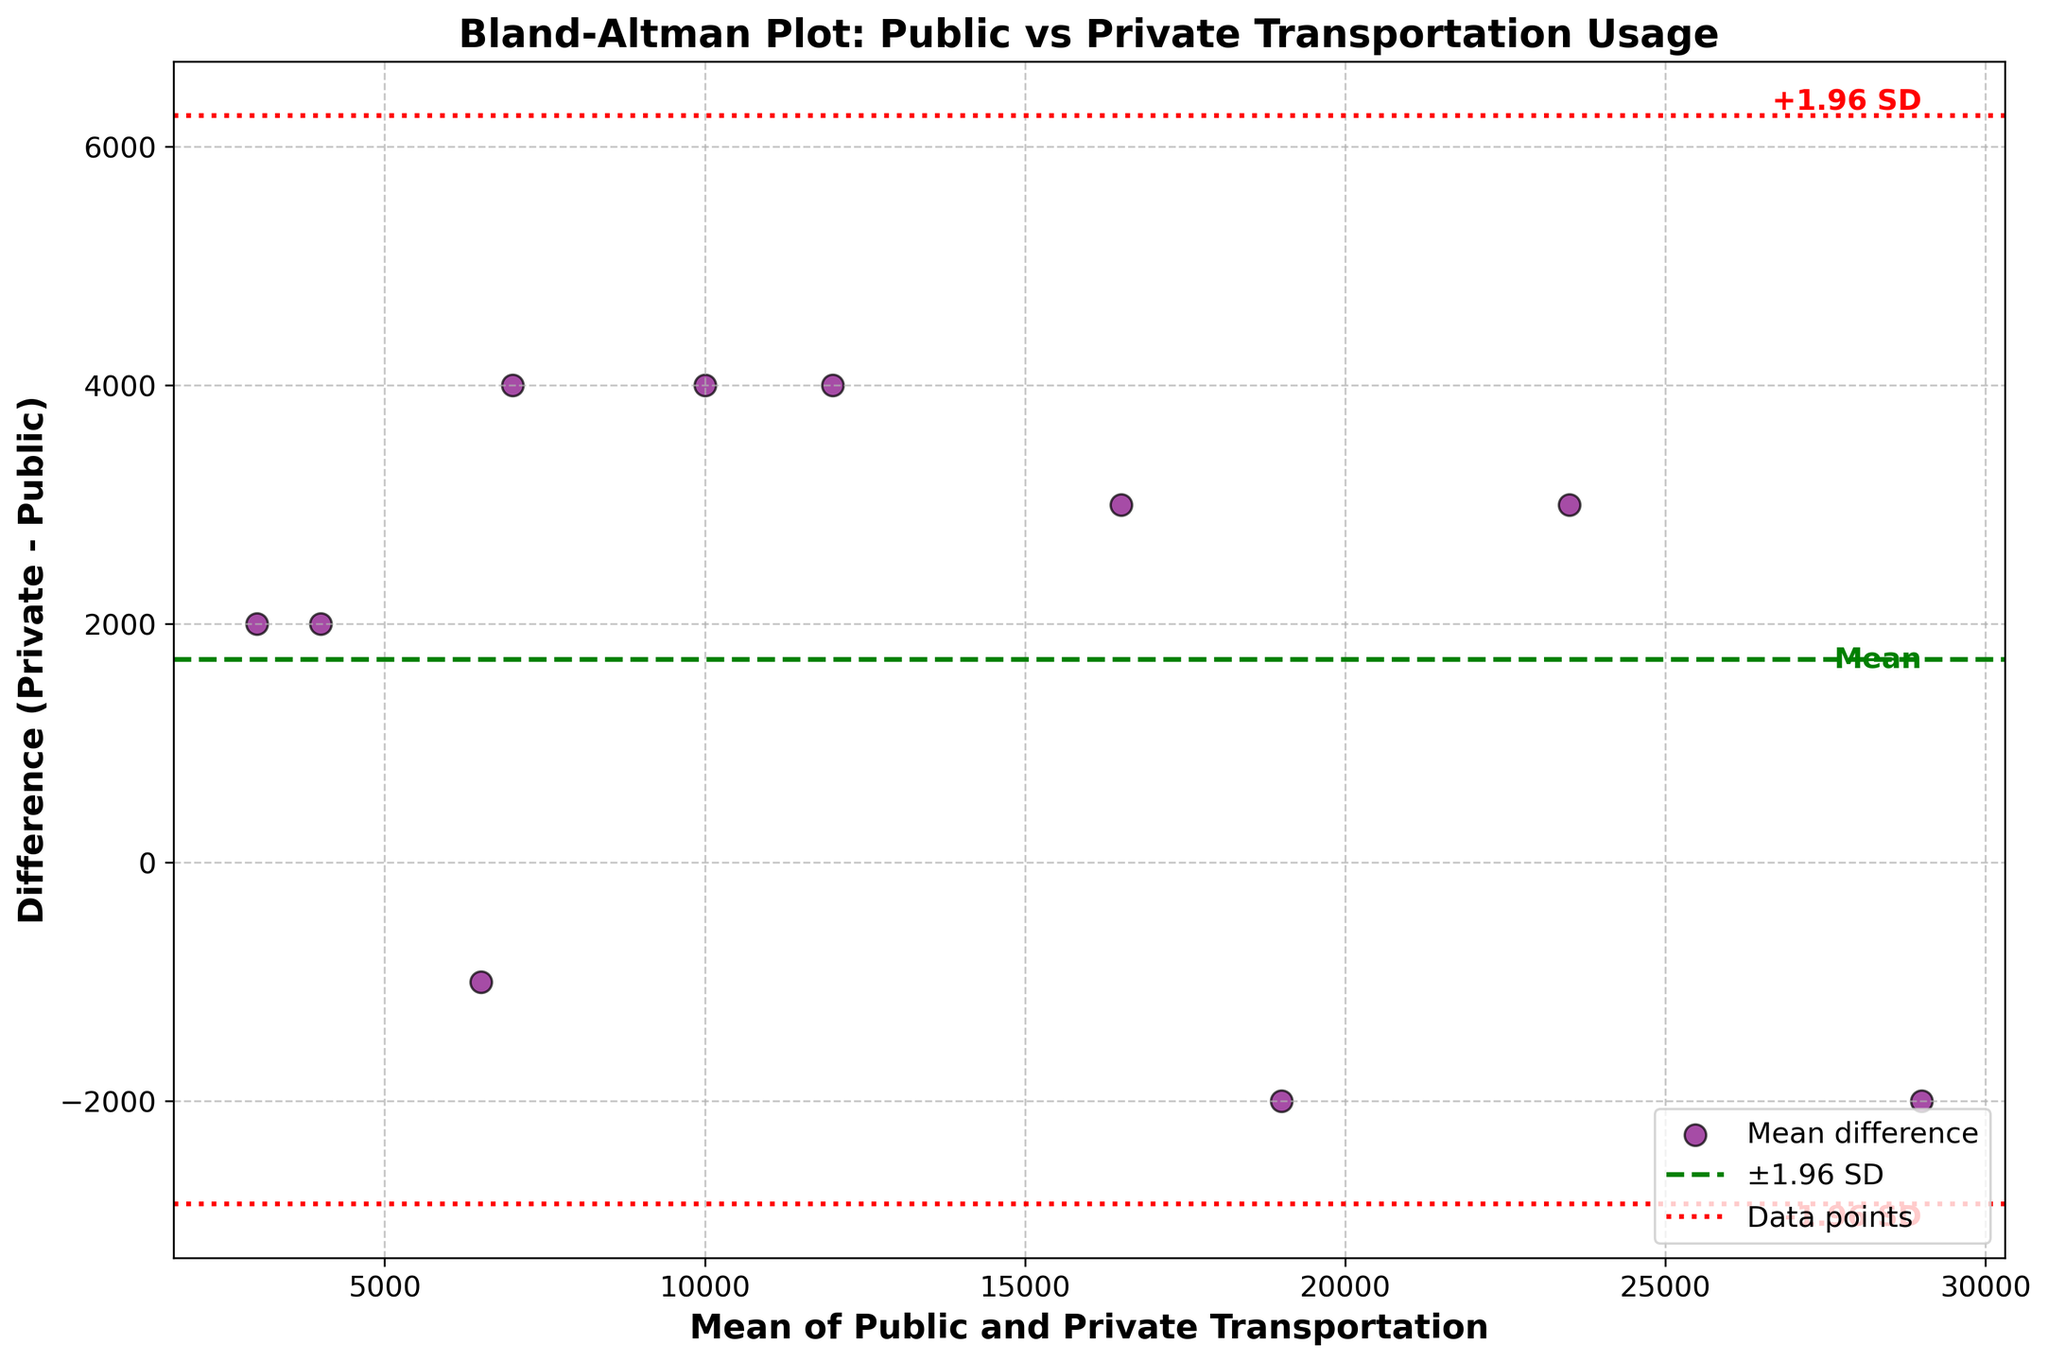What is the title of the figure? The title of the figure is located at the top of the plot, indicating the main subject of the Bland-Altman plot. It provides a clear idea about what is being compared.
Answer: Bland-Altman Plot: Public vs Private Transportation Usage How many data points are plotted on the figure? Each data point represents a method of transportation. By counting all the scattered points in the plot, we can determine the number of observations.
Answer: 10 What does the green dashed line represent? In Bland-Altman plots, the green dashed line typically represents the mean difference (MD) between the two methods being compared (private usage minus public ridership).
Answer: Mean difference What are the values of the red dotted lines? The red dotted lines represent the limits of agreement, which are calculated as the mean difference (MD) ± 1.96 times the standard deviation (SD) of the differences. The y-axis labels where these lines intersect will give their values.
Answer: +1.96 SD and -1.96 SD Which method shows the largest difference between public and private transportation mean usage? This requires identifying the point farthest from the mean (MD) line on the y-axis, which represents the difference between the two usage methods.
Answer: Suburban Rail Line What is the mean (MD) difference between private vehicle usage and public transportation ridership? The mean difference (MD) can be found as the green dashed line's y-axis value, which runs horizontally across the plot.
Answer: Approximately 2330 How is the standard deviation (SD) of the differences depicted visually? The standard deviation is represented by the distance between the mean difference line (green dashed line) and the upper or lower red dotted lines (±1.96 SD).
Answer: Distance between green and red lines For the mean of public and private usage around 15,000, what is the corresponding difference in usage? Locate the average value of 15,000 on the x-axis and observe the y-axis value of the corresponding data point to determine the difference in usage.
Answer: Approximately -3000 Which method's mean usage is closest to 10,000? Find the data point nearest to 10,000 on the mean usage (x-axis) and identify the corresponding method of transportation.
Answer: Intercity Bus Are there more data points above or below the mean difference line? Count the number of data points located above and below the green dashed line to determine whether there are more above or below.
Answer: Below 